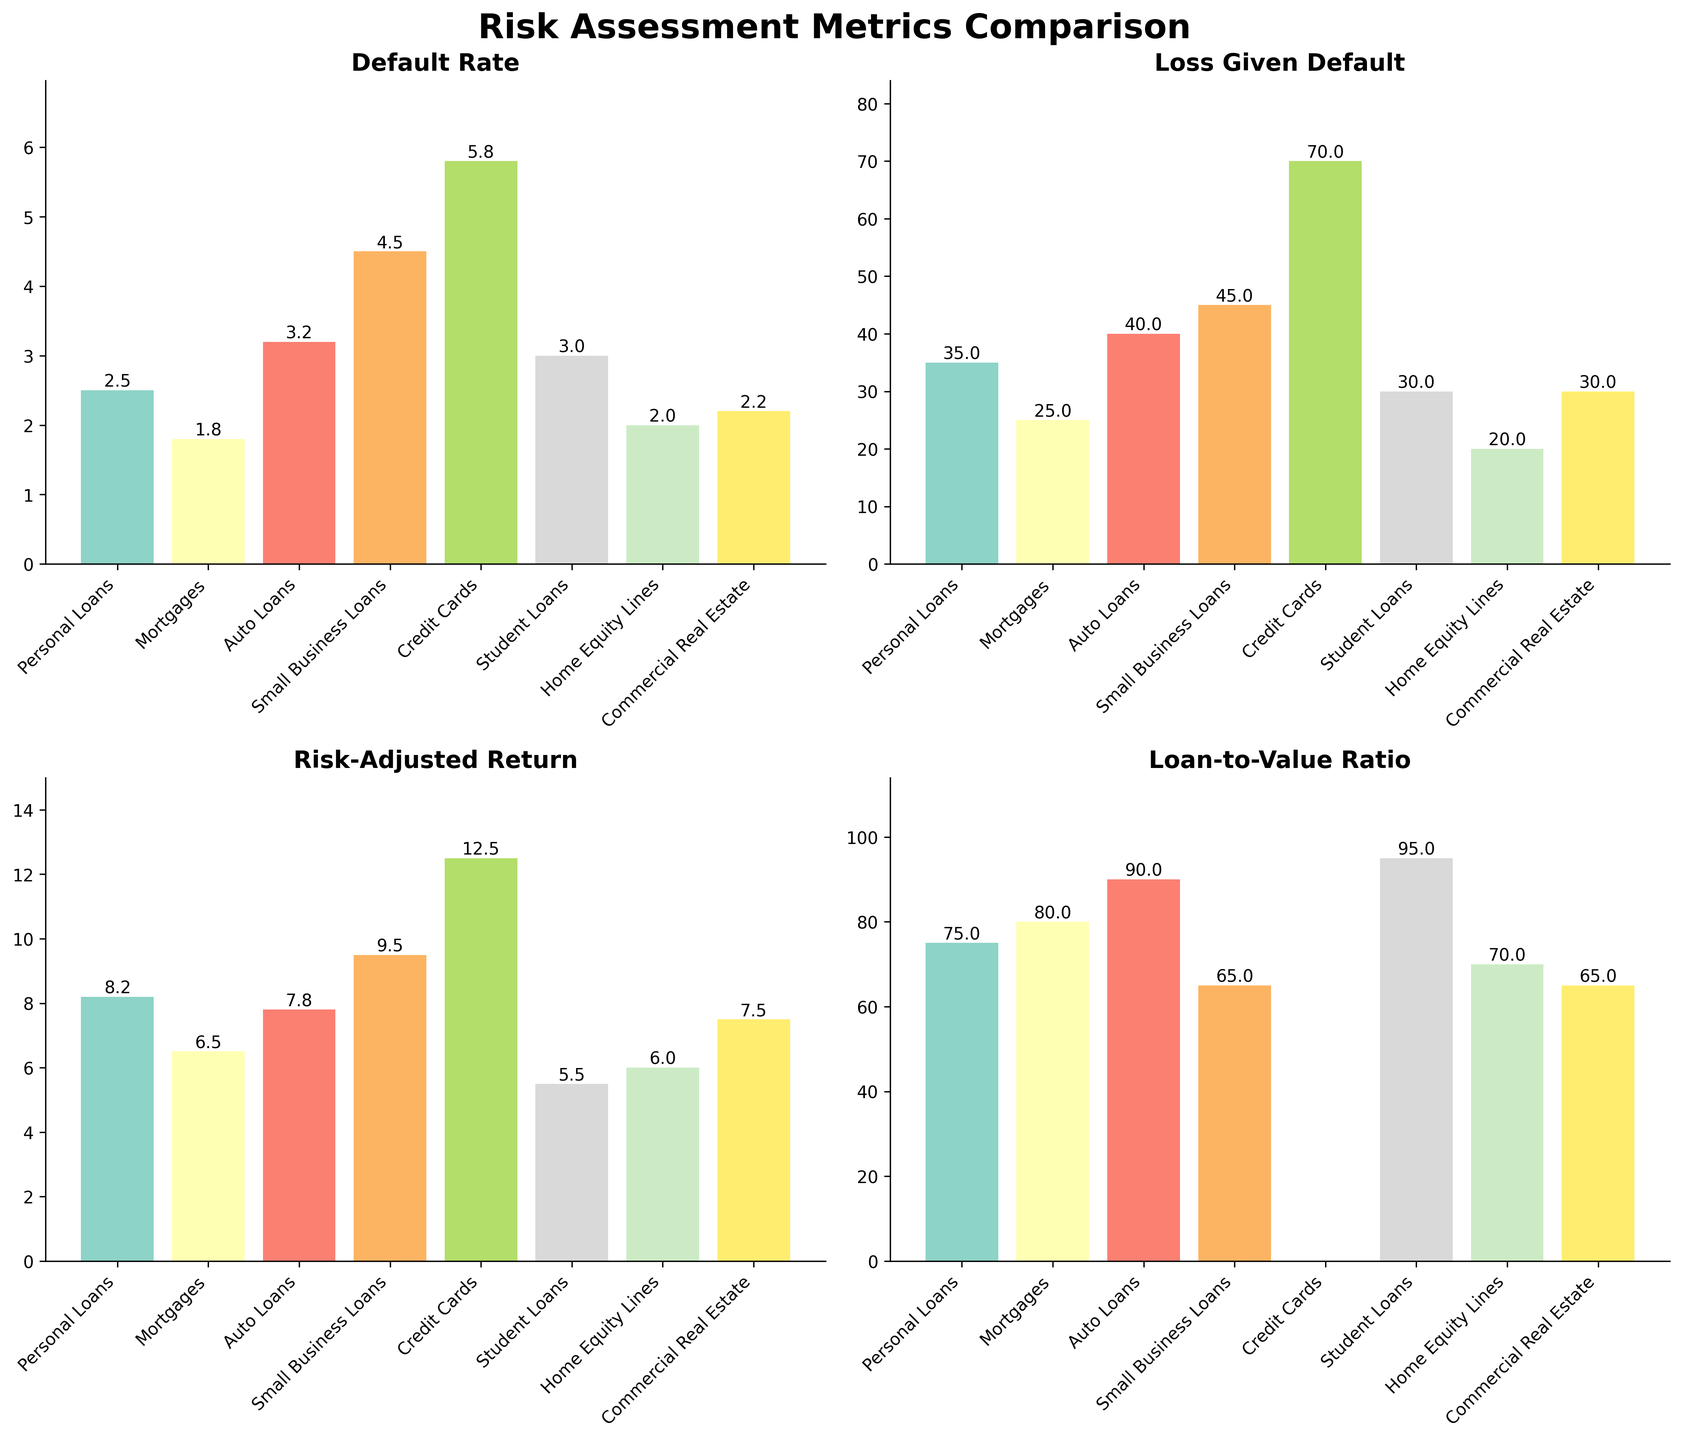How many portfolios are assessed in the plots? The subplots contain bars for each portfolio. By counting the number of bars across all subplots, we find that each plot contains the same number of portfolios. There are 8 portfolios assessed in each subplot.
Answer: 8 Which loan portfolio has the highest Default Rate? The first subplot titled "Default Rate" shows the default rates for each portfolio. The bar for "Credit Cards" is the tallest, indicating it has the highest default rate.
Answer: Credit Cards What is the total Loss Given Default percentage for Personal Loans and Small Business Loans combined? In the second subplot, we locate the bars for "Personal Loans" and "Small Business Loans". The heights of these bars represent their Loss Given Default percentages (35% and 45%, respectively). Adding them together gives 35 + 45 = 80.
Answer: 80 Which metric for Auto Loans is the lowest among the four displayed metrics on the plots? Looking across all 4 subplots, we identify the bar heights for Auto Loans. The metrics are 3.2 for Default Rate, 40 for Loss Given Default, 7.8 for Risk-Adjusted Return, and 90 for Loan-to-Value Ratio. The smallest among these is 3.2.
Answer: Default Rate Is there any portfolio that does not have data for the Loan-to-Value Ratio? In the fourth subplot "Loan-to-Value Ratio", all bars are present except for the "Credit Cards". Thus, "Credit Cards" does not have data for Loan-to-Value Ratio.
Answer: Yes (Credit Cards) Which loan portfolio has the lowest Risk-Adjusted Return? The third subplot titled "Risk-Adjusted Return" presents bars indicating this metric. The shortest bar corresponds to "Student Loans".
Answer: Student Loans Compare Mortgages and Home Equity Lines: Which one has a higher Loss Given Default and by how much? In the second subplot, the Loss Given Default for Mortgages is 25% and for Home Equity Lines is 20%. The difference is 25 - 20 = 5.
Answer: Mortgages by 5 How does the Default Rate of Commercial Real Estate compare to that of Personal Loans? In the first subplot, the Default Rate for Commercial Real Estate is 2.2% while for Personal Loans it is 2.5%. Thus, the Default Rate for Commercial Real Estate is slightly lower.
Answer: Lower Which two portfolios have the exact same Loan-to-Value Ratio, and what is that value? In the fourth subplot, the bars for "Small Business Loans" and "Commercial Real Estate" are at the same height of 65.
Answer: Small Business Loans and Commercial Real Estate, 65 